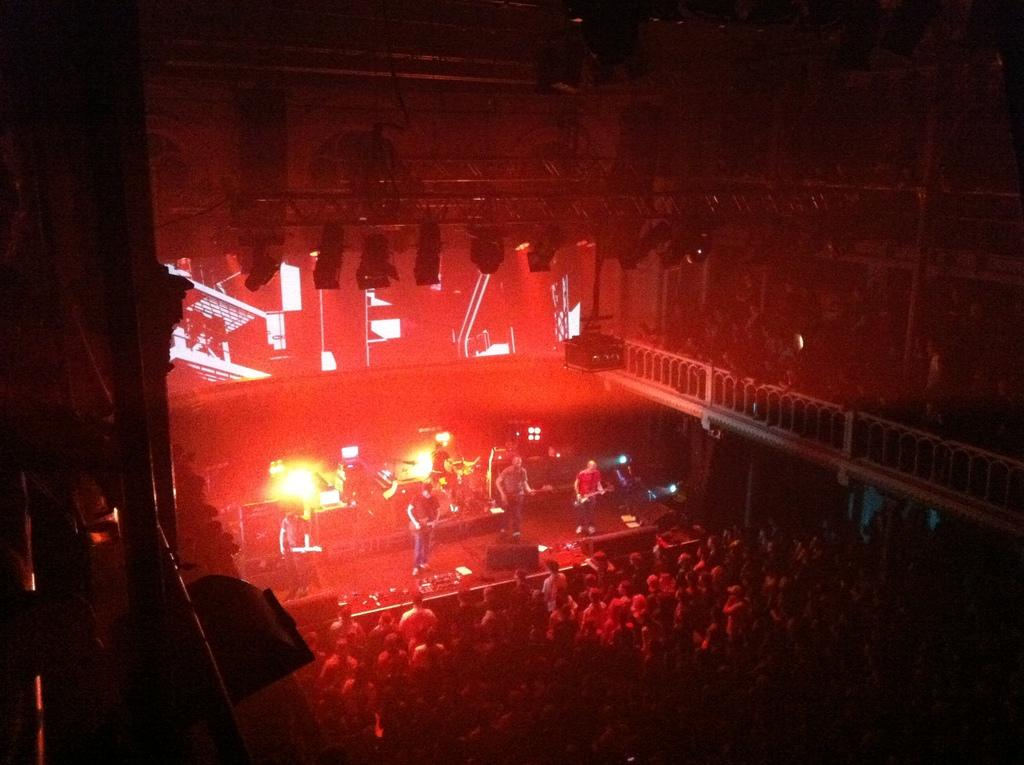What are the people in the image doing? Some people are playing musical instruments. Can you describe the setting in which the people are playing? There are lights visible in the image, and there is a railing present. Where are the lights located in the image? Lights are present at the top of the image. How many members are on the team in the image? There is no team present in the image; it features people playing musical instruments. Is there a beggar visible in the image? There is no beggar present in the image. 